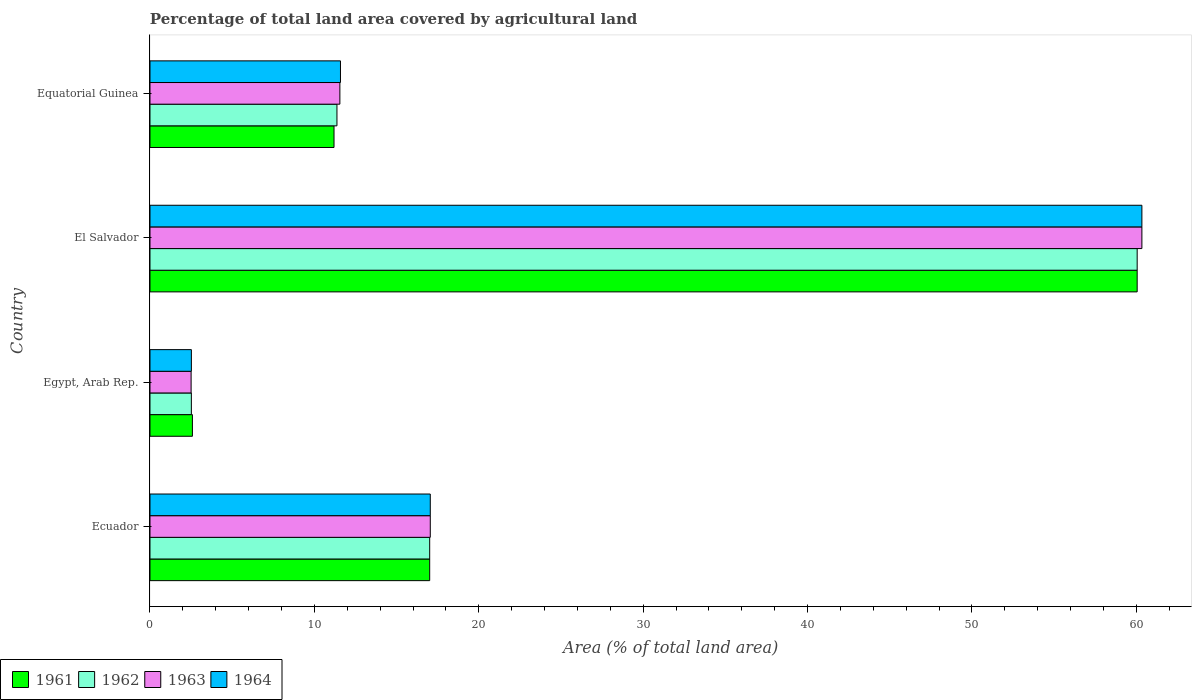Are the number of bars per tick equal to the number of legend labels?
Provide a succinct answer. Yes. Are the number of bars on each tick of the Y-axis equal?
Your answer should be very brief. Yes. How many bars are there on the 2nd tick from the bottom?
Keep it short and to the point. 4. What is the label of the 4th group of bars from the top?
Provide a succinct answer. Ecuador. What is the percentage of agricultural land in 1962 in Equatorial Guinea?
Your answer should be compact. 11.37. Across all countries, what is the maximum percentage of agricultural land in 1964?
Your response must be concise. 60.34. Across all countries, what is the minimum percentage of agricultural land in 1963?
Make the answer very short. 2.5. In which country was the percentage of agricultural land in 1961 maximum?
Offer a very short reply. El Salvador. In which country was the percentage of agricultural land in 1962 minimum?
Offer a very short reply. Egypt, Arab Rep. What is the total percentage of agricultural land in 1964 in the graph?
Ensure brevity in your answer.  91.49. What is the difference between the percentage of agricultural land in 1964 in El Salvador and that in Equatorial Guinea?
Offer a terse response. 48.75. What is the difference between the percentage of agricultural land in 1964 in Egypt, Arab Rep. and the percentage of agricultural land in 1962 in Ecuador?
Offer a terse response. -14.5. What is the average percentage of agricultural land in 1962 per country?
Provide a short and direct response. 22.74. What is the difference between the percentage of agricultural land in 1964 and percentage of agricultural land in 1962 in El Salvador?
Your answer should be very brief. 0.29. In how many countries, is the percentage of agricultural land in 1961 greater than 30 %?
Offer a very short reply. 1. What is the ratio of the percentage of agricultural land in 1961 in El Salvador to that in Equatorial Guinea?
Your answer should be compact. 5.36. Is the percentage of agricultural land in 1964 in Ecuador less than that in Egypt, Arab Rep.?
Give a very brief answer. No. What is the difference between the highest and the second highest percentage of agricultural land in 1962?
Ensure brevity in your answer.  43.03. What is the difference between the highest and the lowest percentage of agricultural land in 1964?
Your answer should be compact. 57.82. In how many countries, is the percentage of agricultural land in 1963 greater than the average percentage of agricultural land in 1963 taken over all countries?
Give a very brief answer. 1. Is the sum of the percentage of agricultural land in 1963 in Ecuador and El Salvador greater than the maximum percentage of agricultural land in 1961 across all countries?
Ensure brevity in your answer.  Yes. What does the 2nd bar from the top in Ecuador represents?
Provide a succinct answer. 1963. What does the 1st bar from the bottom in El Salvador represents?
Your answer should be compact. 1961. Is it the case that in every country, the sum of the percentage of agricultural land in 1961 and percentage of agricultural land in 1962 is greater than the percentage of agricultural land in 1964?
Your response must be concise. Yes. How many bars are there?
Offer a very short reply. 16. Are all the bars in the graph horizontal?
Offer a very short reply. Yes. Are the values on the major ticks of X-axis written in scientific E-notation?
Offer a very short reply. No. Does the graph contain any zero values?
Give a very brief answer. No. Where does the legend appear in the graph?
Make the answer very short. Bottom left. How many legend labels are there?
Keep it short and to the point. 4. How are the legend labels stacked?
Your answer should be very brief. Horizontal. What is the title of the graph?
Ensure brevity in your answer.  Percentage of total land area covered by agricultural land. What is the label or title of the X-axis?
Provide a succinct answer. Area (% of total land area). What is the label or title of the Y-axis?
Provide a short and direct response. Country. What is the Area (% of total land area) in 1961 in Ecuador?
Offer a terse response. 17.01. What is the Area (% of total land area) in 1962 in Ecuador?
Provide a short and direct response. 17.01. What is the Area (% of total land area) of 1963 in Ecuador?
Your answer should be very brief. 17.05. What is the Area (% of total land area) in 1964 in Ecuador?
Keep it short and to the point. 17.05. What is the Area (% of total land area) of 1961 in Egypt, Arab Rep.?
Give a very brief answer. 2.58. What is the Area (% of total land area) in 1962 in Egypt, Arab Rep.?
Keep it short and to the point. 2.52. What is the Area (% of total land area) of 1963 in Egypt, Arab Rep.?
Your answer should be very brief. 2.5. What is the Area (% of total land area) in 1964 in Egypt, Arab Rep.?
Offer a very short reply. 2.52. What is the Area (% of total land area) in 1961 in El Salvador?
Provide a succinct answer. 60.05. What is the Area (% of total land area) in 1962 in El Salvador?
Offer a very short reply. 60.05. What is the Area (% of total land area) in 1963 in El Salvador?
Make the answer very short. 60.34. What is the Area (% of total land area) of 1964 in El Salvador?
Keep it short and to the point. 60.34. What is the Area (% of total land area) of 1961 in Equatorial Guinea?
Your answer should be very brief. 11.19. What is the Area (% of total land area) in 1962 in Equatorial Guinea?
Keep it short and to the point. 11.37. What is the Area (% of total land area) of 1963 in Equatorial Guinea?
Your answer should be compact. 11.55. What is the Area (% of total land area) of 1964 in Equatorial Guinea?
Your response must be concise. 11.59. Across all countries, what is the maximum Area (% of total land area) of 1961?
Offer a very short reply. 60.05. Across all countries, what is the maximum Area (% of total land area) of 1962?
Provide a succinct answer. 60.05. Across all countries, what is the maximum Area (% of total land area) of 1963?
Your response must be concise. 60.34. Across all countries, what is the maximum Area (% of total land area) of 1964?
Your answer should be compact. 60.34. Across all countries, what is the minimum Area (% of total land area) in 1961?
Your answer should be compact. 2.58. Across all countries, what is the minimum Area (% of total land area) in 1962?
Your response must be concise. 2.52. Across all countries, what is the minimum Area (% of total land area) of 1963?
Keep it short and to the point. 2.5. Across all countries, what is the minimum Area (% of total land area) in 1964?
Your response must be concise. 2.52. What is the total Area (% of total land area) of 1961 in the graph?
Your answer should be very brief. 90.84. What is the total Area (% of total land area) of 1962 in the graph?
Offer a terse response. 90.95. What is the total Area (% of total land area) in 1963 in the graph?
Keep it short and to the point. 91.44. What is the total Area (% of total land area) in 1964 in the graph?
Offer a very short reply. 91.49. What is the difference between the Area (% of total land area) of 1961 in Ecuador and that in Egypt, Arab Rep.?
Make the answer very short. 14.43. What is the difference between the Area (% of total land area) of 1962 in Ecuador and that in Egypt, Arab Rep.?
Make the answer very short. 14.5. What is the difference between the Area (% of total land area) of 1963 in Ecuador and that in Egypt, Arab Rep.?
Make the answer very short. 14.55. What is the difference between the Area (% of total land area) in 1964 in Ecuador and that in Egypt, Arab Rep.?
Offer a terse response. 14.53. What is the difference between the Area (% of total land area) of 1961 in Ecuador and that in El Salvador?
Give a very brief answer. -43.03. What is the difference between the Area (% of total land area) in 1962 in Ecuador and that in El Salvador?
Your response must be concise. -43.03. What is the difference between the Area (% of total land area) in 1963 in Ecuador and that in El Salvador?
Ensure brevity in your answer.  -43.29. What is the difference between the Area (% of total land area) of 1964 in Ecuador and that in El Salvador?
Keep it short and to the point. -43.29. What is the difference between the Area (% of total land area) of 1961 in Ecuador and that in Equatorial Guinea?
Ensure brevity in your answer.  5.82. What is the difference between the Area (% of total land area) of 1962 in Ecuador and that in Equatorial Guinea?
Ensure brevity in your answer.  5.64. What is the difference between the Area (% of total land area) of 1963 in Ecuador and that in Equatorial Guinea?
Keep it short and to the point. 5.5. What is the difference between the Area (% of total land area) of 1964 in Ecuador and that in Equatorial Guinea?
Provide a short and direct response. 5.46. What is the difference between the Area (% of total land area) of 1961 in Egypt, Arab Rep. and that in El Salvador?
Ensure brevity in your answer.  -57.47. What is the difference between the Area (% of total land area) of 1962 in Egypt, Arab Rep. and that in El Salvador?
Your answer should be very brief. -57.53. What is the difference between the Area (% of total land area) in 1963 in Egypt, Arab Rep. and that in El Salvador?
Give a very brief answer. -57.83. What is the difference between the Area (% of total land area) of 1964 in Egypt, Arab Rep. and that in El Salvador?
Offer a terse response. -57.82. What is the difference between the Area (% of total land area) in 1961 in Egypt, Arab Rep. and that in Equatorial Guinea?
Keep it short and to the point. -8.61. What is the difference between the Area (% of total land area) in 1962 in Egypt, Arab Rep. and that in Equatorial Guinea?
Provide a short and direct response. -8.86. What is the difference between the Area (% of total land area) of 1963 in Egypt, Arab Rep. and that in Equatorial Guinea?
Offer a very short reply. -9.05. What is the difference between the Area (% of total land area) of 1964 in Egypt, Arab Rep. and that in Equatorial Guinea?
Your answer should be compact. -9.07. What is the difference between the Area (% of total land area) of 1961 in El Salvador and that in Equatorial Guinea?
Offer a very short reply. 48.85. What is the difference between the Area (% of total land area) in 1962 in El Salvador and that in Equatorial Guinea?
Give a very brief answer. 48.68. What is the difference between the Area (% of total land area) in 1963 in El Salvador and that in Equatorial Guinea?
Your answer should be compact. 48.78. What is the difference between the Area (% of total land area) in 1964 in El Salvador and that in Equatorial Guinea?
Make the answer very short. 48.75. What is the difference between the Area (% of total land area) of 1961 in Ecuador and the Area (% of total land area) of 1962 in Egypt, Arab Rep.?
Your answer should be compact. 14.5. What is the difference between the Area (% of total land area) of 1961 in Ecuador and the Area (% of total land area) of 1963 in Egypt, Arab Rep.?
Your answer should be very brief. 14.51. What is the difference between the Area (% of total land area) in 1961 in Ecuador and the Area (% of total land area) in 1964 in Egypt, Arab Rep.?
Your answer should be compact. 14.5. What is the difference between the Area (% of total land area) of 1962 in Ecuador and the Area (% of total land area) of 1963 in Egypt, Arab Rep.?
Make the answer very short. 14.51. What is the difference between the Area (% of total land area) of 1962 in Ecuador and the Area (% of total land area) of 1964 in Egypt, Arab Rep.?
Provide a succinct answer. 14.5. What is the difference between the Area (% of total land area) in 1963 in Ecuador and the Area (% of total land area) in 1964 in Egypt, Arab Rep.?
Provide a succinct answer. 14.53. What is the difference between the Area (% of total land area) in 1961 in Ecuador and the Area (% of total land area) in 1962 in El Salvador?
Offer a very short reply. -43.03. What is the difference between the Area (% of total land area) of 1961 in Ecuador and the Area (% of total land area) of 1963 in El Salvador?
Offer a terse response. -43.32. What is the difference between the Area (% of total land area) in 1961 in Ecuador and the Area (% of total land area) in 1964 in El Salvador?
Ensure brevity in your answer.  -43.32. What is the difference between the Area (% of total land area) in 1962 in Ecuador and the Area (% of total land area) in 1963 in El Salvador?
Provide a short and direct response. -43.32. What is the difference between the Area (% of total land area) in 1962 in Ecuador and the Area (% of total land area) in 1964 in El Salvador?
Ensure brevity in your answer.  -43.32. What is the difference between the Area (% of total land area) in 1963 in Ecuador and the Area (% of total land area) in 1964 in El Salvador?
Offer a terse response. -43.29. What is the difference between the Area (% of total land area) of 1961 in Ecuador and the Area (% of total land area) of 1962 in Equatorial Guinea?
Ensure brevity in your answer.  5.64. What is the difference between the Area (% of total land area) of 1961 in Ecuador and the Area (% of total land area) of 1963 in Equatorial Guinea?
Provide a succinct answer. 5.46. What is the difference between the Area (% of total land area) in 1961 in Ecuador and the Area (% of total land area) in 1964 in Equatorial Guinea?
Your answer should be very brief. 5.43. What is the difference between the Area (% of total land area) in 1962 in Ecuador and the Area (% of total land area) in 1963 in Equatorial Guinea?
Offer a terse response. 5.46. What is the difference between the Area (% of total land area) of 1962 in Ecuador and the Area (% of total land area) of 1964 in Equatorial Guinea?
Offer a very short reply. 5.43. What is the difference between the Area (% of total land area) of 1963 in Ecuador and the Area (% of total land area) of 1964 in Equatorial Guinea?
Your answer should be compact. 5.46. What is the difference between the Area (% of total land area) in 1961 in Egypt, Arab Rep. and the Area (% of total land area) in 1962 in El Salvador?
Your response must be concise. -57.47. What is the difference between the Area (% of total land area) in 1961 in Egypt, Arab Rep. and the Area (% of total land area) in 1963 in El Salvador?
Keep it short and to the point. -57.76. What is the difference between the Area (% of total land area) of 1961 in Egypt, Arab Rep. and the Area (% of total land area) of 1964 in El Salvador?
Make the answer very short. -57.76. What is the difference between the Area (% of total land area) in 1962 in Egypt, Arab Rep. and the Area (% of total land area) in 1963 in El Salvador?
Ensure brevity in your answer.  -57.82. What is the difference between the Area (% of total land area) in 1962 in Egypt, Arab Rep. and the Area (% of total land area) in 1964 in El Salvador?
Keep it short and to the point. -57.82. What is the difference between the Area (% of total land area) in 1963 in Egypt, Arab Rep. and the Area (% of total land area) in 1964 in El Salvador?
Keep it short and to the point. -57.83. What is the difference between the Area (% of total land area) in 1961 in Egypt, Arab Rep. and the Area (% of total land area) in 1962 in Equatorial Guinea?
Ensure brevity in your answer.  -8.79. What is the difference between the Area (% of total land area) in 1961 in Egypt, Arab Rep. and the Area (% of total land area) in 1963 in Equatorial Guinea?
Make the answer very short. -8.97. What is the difference between the Area (% of total land area) in 1961 in Egypt, Arab Rep. and the Area (% of total land area) in 1964 in Equatorial Guinea?
Make the answer very short. -9.01. What is the difference between the Area (% of total land area) in 1962 in Egypt, Arab Rep. and the Area (% of total land area) in 1963 in Equatorial Guinea?
Offer a terse response. -9.03. What is the difference between the Area (% of total land area) of 1962 in Egypt, Arab Rep. and the Area (% of total land area) of 1964 in Equatorial Guinea?
Make the answer very short. -9.07. What is the difference between the Area (% of total land area) in 1963 in Egypt, Arab Rep. and the Area (% of total land area) in 1964 in Equatorial Guinea?
Make the answer very short. -9.09. What is the difference between the Area (% of total land area) in 1961 in El Salvador and the Area (% of total land area) in 1962 in Equatorial Guinea?
Make the answer very short. 48.68. What is the difference between the Area (% of total land area) in 1961 in El Salvador and the Area (% of total land area) in 1963 in Equatorial Guinea?
Give a very brief answer. 48.5. What is the difference between the Area (% of total land area) of 1961 in El Salvador and the Area (% of total land area) of 1964 in Equatorial Guinea?
Ensure brevity in your answer.  48.46. What is the difference between the Area (% of total land area) of 1962 in El Salvador and the Area (% of total land area) of 1963 in Equatorial Guinea?
Provide a succinct answer. 48.5. What is the difference between the Area (% of total land area) in 1962 in El Salvador and the Area (% of total land area) in 1964 in Equatorial Guinea?
Your response must be concise. 48.46. What is the difference between the Area (% of total land area) of 1963 in El Salvador and the Area (% of total land area) of 1964 in Equatorial Guinea?
Keep it short and to the point. 48.75. What is the average Area (% of total land area) in 1961 per country?
Keep it short and to the point. 22.71. What is the average Area (% of total land area) in 1962 per country?
Your response must be concise. 22.74. What is the average Area (% of total land area) in 1963 per country?
Ensure brevity in your answer.  22.86. What is the average Area (% of total land area) of 1964 per country?
Offer a terse response. 22.87. What is the difference between the Area (% of total land area) in 1961 and Area (% of total land area) in 1962 in Ecuador?
Offer a terse response. 0. What is the difference between the Area (% of total land area) in 1961 and Area (% of total land area) in 1963 in Ecuador?
Keep it short and to the point. -0.04. What is the difference between the Area (% of total land area) of 1961 and Area (% of total land area) of 1964 in Ecuador?
Offer a very short reply. -0.04. What is the difference between the Area (% of total land area) of 1962 and Area (% of total land area) of 1963 in Ecuador?
Your answer should be compact. -0.04. What is the difference between the Area (% of total land area) in 1962 and Area (% of total land area) in 1964 in Ecuador?
Ensure brevity in your answer.  -0.04. What is the difference between the Area (% of total land area) of 1963 and Area (% of total land area) of 1964 in Ecuador?
Ensure brevity in your answer.  0. What is the difference between the Area (% of total land area) of 1961 and Area (% of total land area) of 1962 in Egypt, Arab Rep.?
Your answer should be very brief. 0.06. What is the difference between the Area (% of total land area) in 1961 and Area (% of total land area) in 1963 in Egypt, Arab Rep.?
Make the answer very short. 0.08. What is the difference between the Area (% of total land area) in 1961 and Area (% of total land area) in 1964 in Egypt, Arab Rep.?
Ensure brevity in your answer.  0.06. What is the difference between the Area (% of total land area) of 1962 and Area (% of total land area) of 1963 in Egypt, Arab Rep.?
Your answer should be compact. 0.02. What is the difference between the Area (% of total land area) in 1962 and Area (% of total land area) in 1964 in Egypt, Arab Rep.?
Give a very brief answer. -0. What is the difference between the Area (% of total land area) of 1963 and Area (% of total land area) of 1964 in Egypt, Arab Rep.?
Ensure brevity in your answer.  -0.02. What is the difference between the Area (% of total land area) in 1961 and Area (% of total land area) in 1963 in El Salvador?
Provide a succinct answer. -0.29. What is the difference between the Area (% of total land area) in 1961 and Area (% of total land area) in 1964 in El Salvador?
Your response must be concise. -0.29. What is the difference between the Area (% of total land area) in 1962 and Area (% of total land area) in 1963 in El Salvador?
Offer a terse response. -0.29. What is the difference between the Area (% of total land area) in 1962 and Area (% of total land area) in 1964 in El Salvador?
Your answer should be very brief. -0.29. What is the difference between the Area (% of total land area) in 1963 and Area (% of total land area) in 1964 in El Salvador?
Keep it short and to the point. 0. What is the difference between the Area (% of total land area) of 1961 and Area (% of total land area) of 1962 in Equatorial Guinea?
Provide a succinct answer. -0.18. What is the difference between the Area (% of total land area) in 1961 and Area (% of total land area) in 1963 in Equatorial Guinea?
Give a very brief answer. -0.36. What is the difference between the Area (% of total land area) of 1961 and Area (% of total land area) of 1964 in Equatorial Guinea?
Keep it short and to the point. -0.39. What is the difference between the Area (% of total land area) of 1962 and Area (% of total land area) of 1963 in Equatorial Guinea?
Your answer should be very brief. -0.18. What is the difference between the Area (% of total land area) in 1962 and Area (% of total land area) in 1964 in Equatorial Guinea?
Your response must be concise. -0.21. What is the difference between the Area (% of total land area) of 1963 and Area (% of total land area) of 1964 in Equatorial Guinea?
Provide a succinct answer. -0.04. What is the ratio of the Area (% of total land area) in 1961 in Ecuador to that in Egypt, Arab Rep.?
Make the answer very short. 6.59. What is the ratio of the Area (% of total land area) of 1962 in Ecuador to that in Egypt, Arab Rep.?
Make the answer very short. 6.76. What is the ratio of the Area (% of total land area) in 1963 in Ecuador to that in Egypt, Arab Rep.?
Provide a short and direct response. 6.82. What is the ratio of the Area (% of total land area) of 1964 in Ecuador to that in Egypt, Arab Rep.?
Keep it short and to the point. 6.77. What is the ratio of the Area (% of total land area) in 1961 in Ecuador to that in El Salvador?
Make the answer very short. 0.28. What is the ratio of the Area (% of total land area) of 1962 in Ecuador to that in El Salvador?
Offer a very short reply. 0.28. What is the ratio of the Area (% of total land area) of 1963 in Ecuador to that in El Salvador?
Offer a terse response. 0.28. What is the ratio of the Area (% of total land area) in 1964 in Ecuador to that in El Salvador?
Offer a very short reply. 0.28. What is the ratio of the Area (% of total land area) of 1961 in Ecuador to that in Equatorial Guinea?
Ensure brevity in your answer.  1.52. What is the ratio of the Area (% of total land area) in 1962 in Ecuador to that in Equatorial Guinea?
Give a very brief answer. 1.5. What is the ratio of the Area (% of total land area) in 1963 in Ecuador to that in Equatorial Guinea?
Give a very brief answer. 1.48. What is the ratio of the Area (% of total land area) of 1964 in Ecuador to that in Equatorial Guinea?
Offer a very short reply. 1.47. What is the ratio of the Area (% of total land area) of 1961 in Egypt, Arab Rep. to that in El Salvador?
Your response must be concise. 0.04. What is the ratio of the Area (% of total land area) in 1962 in Egypt, Arab Rep. to that in El Salvador?
Your answer should be very brief. 0.04. What is the ratio of the Area (% of total land area) of 1963 in Egypt, Arab Rep. to that in El Salvador?
Offer a terse response. 0.04. What is the ratio of the Area (% of total land area) of 1964 in Egypt, Arab Rep. to that in El Salvador?
Your answer should be very brief. 0.04. What is the ratio of the Area (% of total land area) in 1961 in Egypt, Arab Rep. to that in Equatorial Guinea?
Keep it short and to the point. 0.23. What is the ratio of the Area (% of total land area) in 1962 in Egypt, Arab Rep. to that in Equatorial Guinea?
Keep it short and to the point. 0.22. What is the ratio of the Area (% of total land area) in 1963 in Egypt, Arab Rep. to that in Equatorial Guinea?
Ensure brevity in your answer.  0.22. What is the ratio of the Area (% of total land area) in 1964 in Egypt, Arab Rep. to that in Equatorial Guinea?
Offer a very short reply. 0.22. What is the ratio of the Area (% of total land area) of 1961 in El Salvador to that in Equatorial Guinea?
Your response must be concise. 5.36. What is the ratio of the Area (% of total land area) in 1962 in El Salvador to that in Equatorial Guinea?
Provide a short and direct response. 5.28. What is the ratio of the Area (% of total land area) of 1963 in El Salvador to that in Equatorial Guinea?
Your answer should be very brief. 5.22. What is the ratio of the Area (% of total land area) of 1964 in El Salvador to that in Equatorial Guinea?
Your answer should be compact. 5.21. What is the difference between the highest and the second highest Area (% of total land area) in 1961?
Keep it short and to the point. 43.03. What is the difference between the highest and the second highest Area (% of total land area) in 1962?
Keep it short and to the point. 43.03. What is the difference between the highest and the second highest Area (% of total land area) in 1963?
Provide a succinct answer. 43.29. What is the difference between the highest and the second highest Area (% of total land area) in 1964?
Your answer should be compact. 43.29. What is the difference between the highest and the lowest Area (% of total land area) in 1961?
Ensure brevity in your answer.  57.47. What is the difference between the highest and the lowest Area (% of total land area) in 1962?
Your answer should be compact. 57.53. What is the difference between the highest and the lowest Area (% of total land area) of 1963?
Your answer should be compact. 57.83. What is the difference between the highest and the lowest Area (% of total land area) of 1964?
Offer a terse response. 57.82. 